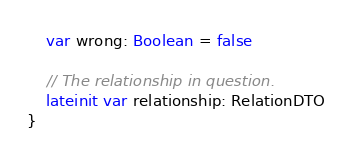<code> <loc_0><loc_0><loc_500><loc_500><_Kotlin_>    var wrong: Boolean = false

    // The relationship in question.
    lateinit var relationship: RelationDTO
}</code> 